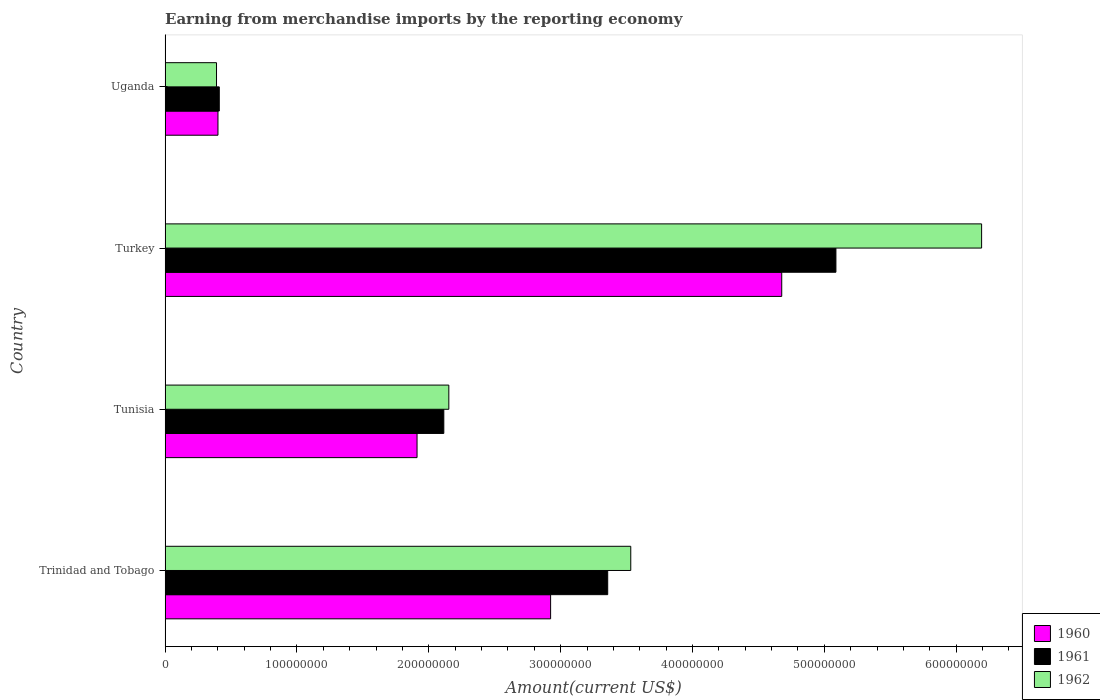How many different coloured bars are there?
Your response must be concise. 3. Are the number of bars per tick equal to the number of legend labels?
Offer a very short reply. Yes. How many bars are there on the 3rd tick from the top?
Your answer should be very brief. 3. How many bars are there on the 2nd tick from the bottom?
Give a very brief answer. 3. What is the label of the 1st group of bars from the top?
Offer a very short reply. Uganda. What is the amount earned from merchandise imports in 1962 in Tunisia?
Give a very brief answer. 2.15e+08. Across all countries, what is the maximum amount earned from merchandise imports in 1961?
Give a very brief answer. 5.09e+08. Across all countries, what is the minimum amount earned from merchandise imports in 1961?
Make the answer very short. 4.11e+07. In which country was the amount earned from merchandise imports in 1961 maximum?
Offer a terse response. Turkey. In which country was the amount earned from merchandise imports in 1961 minimum?
Offer a very short reply. Uganda. What is the total amount earned from merchandise imports in 1960 in the graph?
Your answer should be compact. 9.91e+08. What is the difference between the amount earned from merchandise imports in 1962 in Turkey and that in Uganda?
Offer a very short reply. 5.80e+08. What is the difference between the amount earned from merchandise imports in 1961 in Uganda and the amount earned from merchandise imports in 1962 in Trinidad and Tobago?
Provide a succinct answer. -3.12e+08. What is the average amount earned from merchandise imports in 1961 per country?
Your answer should be compact. 2.74e+08. What is the difference between the amount earned from merchandise imports in 1962 and amount earned from merchandise imports in 1960 in Trinidad and Tobago?
Give a very brief answer. 6.08e+07. In how many countries, is the amount earned from merchandise imports in 1962 greater than 500000000 US$?
Ensure brevity in your answer.  1. What is the ratio of the amount earned from merchandise imports in 1962 in Tunisia to that in Uganda?
Keep it short and to the point. 5.52. Is the amount earned from merchandise imports in 1960 in Tunisia less than that in Turkey?
Your answer should be very brief. Yes. Is the difference between the amount earned from merchandise imports in 1962 in Tunisia and Uganda greater than the difference between the amount earned from merchandise imports in 1960 in Tunisia and Uganda?
Offer a very short reply. Yes. What is the difference between the highest and the second highest amount earned from merchandise imports in 1960?
Your answer should be very brief. 1.75e+08. What is the difference between the highest and the lowest amount earned from merchandise imports in 1962?
Your answer should be compact. 5.80e+08. Is the sum of the amount earned from merchandise imports in 1961 in Turkey and Uganda greater than the maximum amount earned from merchandise imports in 1962 across all countries?
Keep it short and to the point. No. What does the 3rd bar from the top in Trinidad and Tobago represents?
Provide a succinct answer. 1960. What does the 2nd bar from the bottom in Tunisia represents?
Your answer should be compact. 1961. How many bars are there?
Keep it short and to the point. 12. What is the difference between two consecutive major ticks on the X-axis?
Offer a terse response. 1.00e+08. Does the graph contain any zero values?
Provide a succinct answer. No. Does the graph contain grids?
Your response must be concise. No. Where does the legend appear in the graph?
Make the answer very short. Bottom right. How are the legend labels stacked?
Ensure brevity in your answer.  Vertical. What is the title of the graph?
Ensure brevity in your answer.  Earning from merchandise imports by the reporting economy. What is the label or title of the X-axis?
Make the answer very short. Amount(current US$). What is the label or title of the Y-axis?
Provide a short and direct response. Country. What is the Amount(current US$) in 1960 in Trinidad and Tobago?
Offer a very short reply. 2.92e+08. What is the Amount(current US$) in 1961 in Trinidad and Tobago?
Provide a short and direct response. 3.36e+08. What is the Amount(current US$) in 1962 in Trinidad and Tobago?
Your response must be concise. 3.53e+08. What is the Amount(current US$) of 1960 in Tunisia?
Your response must be concise. 1.91e+08. What is the Amount(current US$) in 1961 in Tunisia?
Offer a terse response. 2.11e+08. What is the Amount(current US$) of 1962 in Tunisia?
Offer a very short reply. 2.15e+08. What is the Amount(current US$) in 1960 in Turkey?
Ensure brevity in your answer.  4.68e+08. What is the Amount(current US$) of 1961 in Turkey?
Make the answer very short. 5.09e+08. What is the Amount(current US$) of 1962 in Turkey?
Your response must be concise. 6.19e+08. What is the Amount(current US$) in 1960 in Uganda?
Keep it short and to the point. 4.01e+07. What is the Amount(current US$) in 1961 in Uganda?
Keep it short and to the point. 4.11e+07. What is the Amount(current US$) of 1962 in Uganda?
Your answer should be very brief. 3.90e+07. Across all countries, what is the maximum Amount(current US$) in 1960?
Give a very brief answer. 4.68e+08. Across all countries, what is the maximum Amount(current US$) of 1961?
Provide a short and direct response. 5.09e+08. Across all countries, what is the maximum Amount(current US$) of 1962?
Your answer should be compact. 6.19e+08. Across all countries, what is the minimum Amount(current US$) of 1960?
Your answer should be very brief. 4.01e+07. Across all countries, what is the minimum Amount(current US$) in 1961?
Your answer should be compact. 4.11e+07. Across all countries, what is the minimum Amount(current US$) of 1962?
Your response must be concise. 3.90e+07. What is the total Amount(current US$) in 1960 in the graph?
Provide a succinct answer. 9.91e+08. What is the total Amount(current US$) in 1961 in the graph?
Provide a succinct answer. 1.10e+09. What is the total Amount(current US$) of 1962 in the graph?
Give a very brief answer. 1.23e+09. What is the difference between the Amount(current US$) in 1960 in Trinidad and Tobago and that in Tunisia?
Your answer should be compact. 1.01e+08. What is the difference between the Amount(current US$) of 1961 in Trinidad and Tobago and that in Tunisia?
Make the answer very short. 1.24e+08. What is the difference between the Amount(current US$) in 1962 in Trinidad and Tobago and that in Tunisia?
Offer a terse response. 1.38e+08. What is the difference between the Amount(current US$) of 1960 in Trinidad and Tobago and that in Turkey?
Give a very brief answer. -1.75e+08. What is the difference between the Amount(current US$) in 1961 in Trinidad and Tobago and that in Turkey?
Give a very brief answer. -1.73e+08. What is the difference between the Amount(current US$) of 1962 in Trinidad and Tobago and that in Turkey?
Provide a short and direct response. -2.66e+08. What is the difference between the Amount(current US$) in 1960 in Trinidad and Tobago and that in Uganda?
Offer a terse response. 2.52e+08. What is the difference between the Amount(current US$) of 1961 in Trinidad and Tobago and that in Uganda?
Your answer should be very brief. 2.95e+08. What is the difference between the Amount(current US$) of 1962 in Trinidad and Tobago and that in Uganda?
Provide a succinct answer. 3.14e+08. What is the difference between the Amount(current US$) in 1960 in Tunisia and that in Turkey?
Provide a succinct answer. -2.77e+08. What is the difference between the Amount(current US$) in 1961 in Tunisia and that in Turkey?
Make the answer very short. -2.97e+08. What is the difference between the Amount(current US$) of 1962 in Tunisia and that in Turkey?
Your answer should be very brief. -4.04e+08. What is the difference between the Amount(current US$) of 1960 in Tunisia and that in Uganda?
Your response must be concise. 1.51e+08. What is the difference between the Amount(current US$) of 1961 in Tunisia and that in Uganda?
Make the answer very short. 1.70e+08. What is the difference between the Amount(current US$) in 1962 in Tunisia and that in Uganda?
Ensure brevity in your answer.  1.76e+08. What is the difference between the Amount(current US$) of 1960 in Turkey and that in Uganda?
Your answer should be compact. 4.28e+08. What is the difference between the Amount(current US$) in 1961 in Turkey and that in Uganda?
Your response must be concise. 4.68e+08. What is the difference between the Amount(current US$) of 1962 in Turkey and that in Uganda?
Your answer should be very brief. 5.80e+08. What is the difference between the Amount(current US$) of 1960 in Trinidad and Tobago and the Amount(current US$) of 1961 in Tunisia?
Give a very brief answer. 8.10e+07. What is the difference between the Amount(current US$) of 1960 in Trinidad and Tobago and the Amount(current US$) of 1962 in Tunisia?
Your response must be concise. 7.72e+07. What is the difference between the Amount(current US$) of 1961 in Trinidad and Tobago and the Amount(current US$) of 1962 in Tunisia?
Your response must be concise. 1.20e+08. What is the difference between the Amount(current US$) of 1960 in Trinidad and Tobago and the Amount(current US$) of 1961 in Turkey?
Your answer should be compact. -2.16e+08. What is the difference between the Amount(current US$) in 1960 in Trinidad and Tobago and the Amount(current US$) in 1962 in Turkey?
Your answer should be compact. -3.27e+08. What is the difference between the Amount(current US$) in 1961 in Trinidad and Tobago and the Amount(current US$) in 1962 in Turkey?
Your answer should be compact. -2.84e+08. What is the difference between the Amount(current US$) in 1960 in Trinidad and Tobago and the Amount(current US$) in 1961 in Uganda?
Give a very brief answer. 2.51e+08. What is the difference between the Amount(current US$) of 1960 in Trinidad and Tobago and the Amount(current US$) of 1962 in Uganda?
Offer a very short reply. 2.53e+08. What is the difference between the Amount(current US$) in 1961 in Trinidad and Tobago and the Amount(current US$) in 1962 in Uganda?
Your answer should be compact. 2.97e+08. What is the difference between the Amount(current US$) of 1960 in Tunisia and the Amount(current US$) of 1961 in Turkey?
Keep it short and to the point. -3.18e+08. What is the difference between the Amount(current US$) of 1960 in Tunisia and the Amount(current US$) of 1962 in Turkey?
Provide a succinct answer. -4.28e+08. What is the difference between the Amount(current US$) in 1961 in Tunisia and the Amount(current US$) in 1962 in Turkey?
Make the answer very short. -4.08e+08. What is the difference between the Amount(current US$) in 1960 in Tunisia and the Amount(current US$) in 1961 in Uganda?
Keep it short and to the point. 1.50e+08. What is the difference between the Amount(current US$) of 1960 in Tunisia and the Amount(current US$) of 1962 in Uganda?
Keep it short and to the point. 1.52e+08. What is the difference between the Amount(current US$) of 1961 in Tunisia and the Amount(current US$) of 1962 in Uganda?
Provide a succinct answer. 1.72e+08. What is the difference between the Amount(current US$) of 1960 in Turkey and the Amount(current US$) of 1961 in Uganda?
Make the answer very short. 4.27e+08. What is the difference between the Amount(current US$) in 1960 in Turkey and the Amount(current US$) in 1962 in Uganda?
Provide a short and direct response. 4.29e+08. What is the difference between the Amount(current US$) of 1961 in Turkey and the Amount(current US$) of 1962 in Uganda?
Your response must be concise. 4.70e+08. What is the average Amount(current US$) of 1960 per country?
Your response must be concise. 2.48e+08. What is the average Amount(current US$) of 1961 per country?
Your answer should be very brief. 2.74e+08. What is the average Amount(current US$) of 1962 per country?
Ensure brevity in your answer.  3.07e+08. What is the difference between the Amount(current US$) in 1960 and Amount(current US$) in 1961 in Trinidad and Tobago?
Offer a very short reply. -4.33e+07. What is the difference between the Amount(current US$) of 1960 and Amount(current US$) of 1962 in Trinidad and Tobago?
Make the answer very short. -6.08e+07. What is the difference between the Amount(current US$) in 1961 and Amount(current US$) in 1962 in Trinidad and Tobago?
Keep it short and to the point. -1.75e+07. What is the difference between the Amount(current US$) in 1960 and Amount(current US$) in 1961 in Tunisia?
Your answer should be compact. -2.03e+07. What is the difference between the Amount(current US$) of 1960 and Amount(current US$) of 1962 in Tunisia?
Your response must be concise. -2.41e+07. What is the difference between the Amount(current US$) in 1961 and Amount(current US$) in 1962 in Tunisia?
Your response must be concise. -3.80e+06. What is the difference between the Amount(current US$) of 1960 and Amount(current US$) of 1961 in Turkey?
Offer a terse response. -4.11e+07. What is the difference between the Amount(current US$) in 1960 and Amount(current US$) in 1962 in Turkey?
Give a very brief answer. -1.52e+08. What is the difference between the Amount(current US$) in 1961 and Amount(current US$) in 1962 in Turkey?
Provide a short and direct response. -1.10e+08. What is the difference between the Amount(current US$) of 1960 and Amount(current US$) of 1961 in Uganda?
Your answer should be very brief. -1.00e+06. What is the difference between the Amount(current US$) of 1960 and Amount(current US$) of 1962 in Uganda?
Your answer should be very brief. 1.10e+06. What is the difference between the Amount(current US$) of 1961 and Amount(current US$) of 1962 in Uganda?
Offer a terse response. 2.10e+06. What is the ratio of the Amount(current US$) of 1960 in Trinidad and Tobago to that in Tunisia?
Keep it short and to the point. 1.53. What is the ratio of the Amount(current US$) in 1961 in Trinidad and Tobago to that in Tunisia?
Your response must be concise. 1.59. What is the ratio of the Amount(current US$) in 1962 in Trinidad and Tobago to that in Tunisia?
Your answer should be very brief. 1.64. What is the ratio of the Amount(current US$) in 1960 in Trinidad and Tobago to that in Turkey?
Your response must be concise. 0.63. What is the ratio of the Amount(current US$) in 1961 in Trinidad and Tobago to that in Turkey?
Offer a very short reply. 0.66. What is the ratio of the Amount(current US$) in 1962 in Trinidad and Tobago to that in Turkey?
Your response must be concise. 0.57. What is the ratio of the Amount(current US$) in 1960 in Trinidad and Tobago to that in Uganda?
Offer a terse response. 7.29. What is the ratio of the Amount(current US$) in 1961 in Trinidad and Tobago to that in Uganda?
Make the answer very short. 8.17. What is the ratio of the Amount(current US$) in 1962 in Trinidad and Tobago to that in Uganda?
Your answer should be compact. 9.06. What is the ratio of the Amount(current US$) of 1960 in Tunisia to that in Turkey?
Offer a very short reply. 0.41. What is the ratio of the Amount(current US$) in 1961 in Tunisia to that in Turkey?
Provide a short and direct response. 0.42. What is the ratio of the Amount(current US$) of 1962 in Tunisia to that in Turkey?
Make the answer very short. 0.35. What is the ratio of the Amount(current US$) of 1960 in Tunisia to that in Uganda?
Keep it short and to the point. 4.77. What is the ratio of the Amount(current US$) in 1961 in Tunisia to that in Uganda?
Your response must be concise. 5.14. What is the ratio of the Amount(current US$) of 1962 in Tunisia to that in Uganda?
Provide a succinct answer. 5.52. What is the ratio of the Amount(current US$) in 1960 in Turkey to that in Uganda?
Offer a terse response. 11.66. What is the ratio of the Amount(current US$) in 1961 in Turkey to that in Uganda?
Your answer should be compact. 12.38. What is the ratio of the Amount(current US$) in 1962 in Turkey to that in Uganda?
Ensure brevity in your answer.  15.88. What is the difference between the highest and the second highest Amount(current US$) in 1960?
Offer a terse response. 1.75e+08. What is the difference between the highest and the second highest Amount(current US$) of 1961?
Offer a very short reply. 1.73e+08. What is the difference between the highest and the second highest Amount(current US$) in 1962?
Offer a very short reply. 2.66e+08. What is the difference between the highest and the lowest Amount(current US$) in 1960?
Provide a short and direct response. 4.28e+08. What is the difference between the highest and the lowest Amount(current US$) in 1961?
Provide a short and direct response. 4.68e+08. What is the difference between the highest and the lowest Amount(current US$) in 1962?
Ensure brevity in your answer.  5.80e+08. 